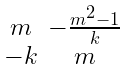<formula> <loc_0><loc_0><loc_500><loc_500>\begin{smallmatrix} m & - \frac { m ^ { 2 } - 1 } { k } \\ - k & m \end{smallmatrix}</formula> 